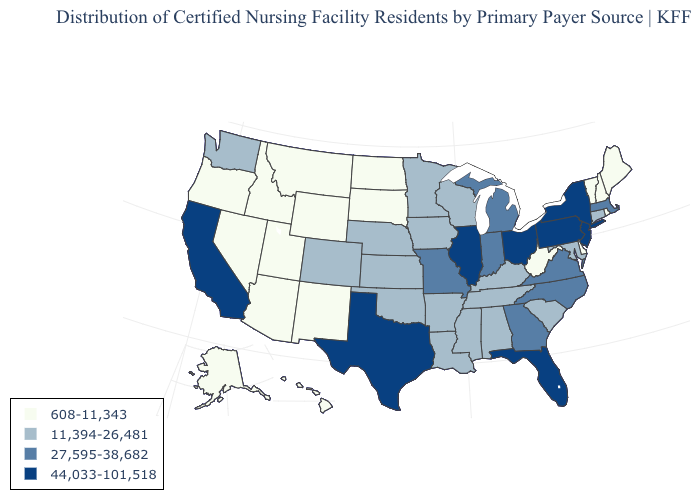What is the highest value in states that border Pennsylvania?
Quick response, please. 44,033-101,518. Does the first symbol in the legend represent the smallest category?
Write a very short answer. Yes. Which states have the lowest value in the South?
Be succinct. Delaware, West Virginia. Name the states that have a value in the range 44,033-101,518?
Give a very brief answer. California, Florida, Illinois, New Jersey, New York, Ohio, Pennsylvania, Texas. Name the states that have a value in the range 11,394-26,481?
Concise answer only. Alabama, Arkansas, Colorado, Connecticut, Iowa, Kansas, Kentucky, Louisiana, Maryland, Minnesota, Mississippi, Nebraska, Oklahoma, South Carolina, Tennessee, Washington, Wisconsin. Does Florida have the highest value in the South?
Quick response, please. Yes. What is the highest value in the West ?
Quick response, please. 44,033-101,518. What is the value of Alaska?
Concise answer only. 608-11,343. What is the highest value in the West ?
Give a very brief answer. 44,033-101,518. Does Massachusetts have the lowest value in the Northeast?
Short answer required. No. What is the highest value in the USA?
Answer briefly. 44,033-101,518. Which states hav the highest value in the Northeast?
Give a very brief answer. New Jersey, New York, Pennsylvania. What is the value of Hawaii?
Short answer required. 608-11,343. What is the value of Arkansas?
Answer briefly. 11,394-26,481. 